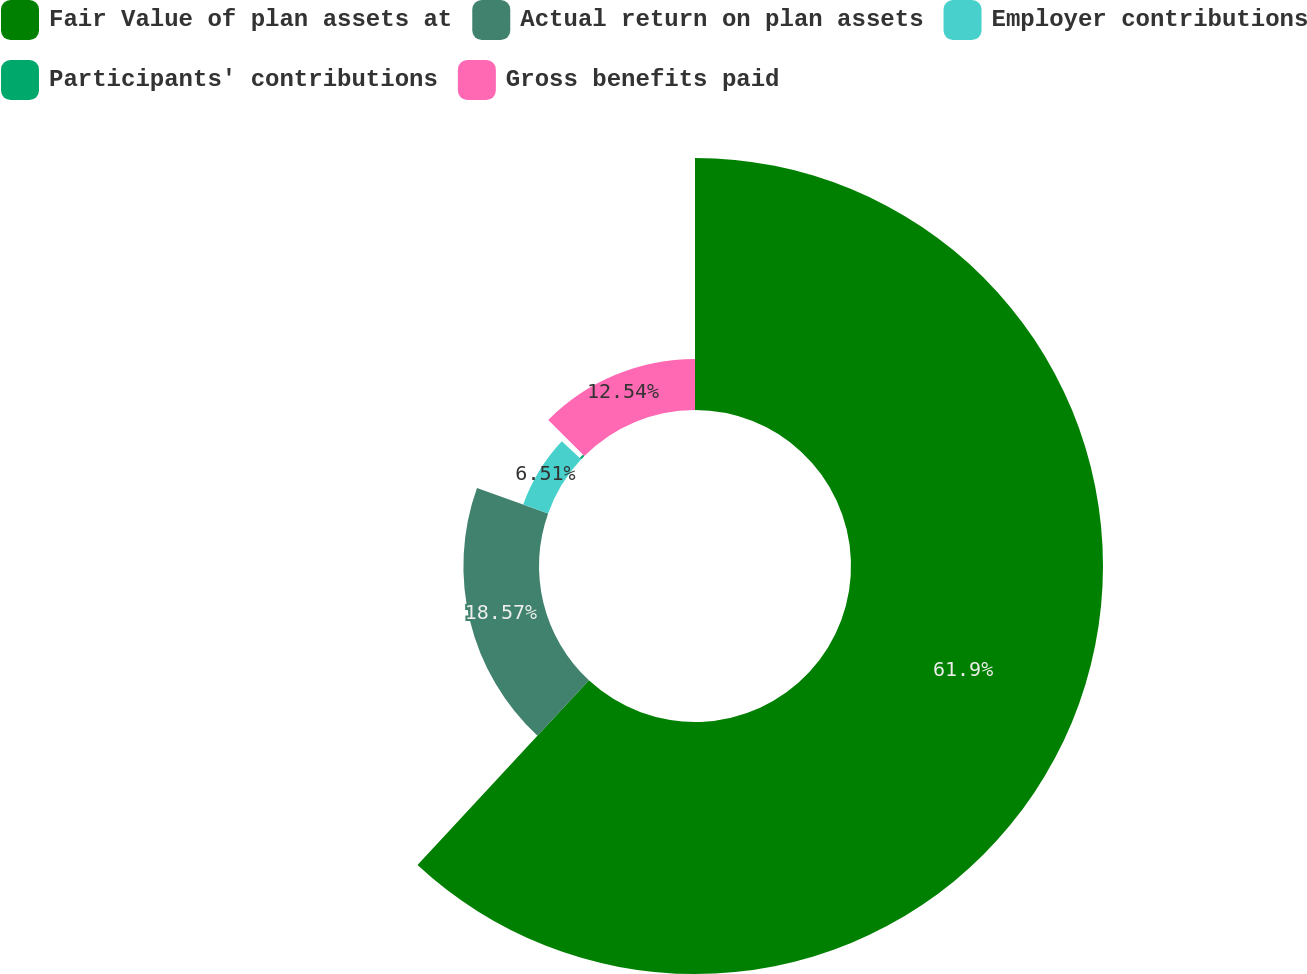Convert chart to OTSL. <chart><loc_0><loc_0><loc_500><loc_500><pie_chart><fcel>Fair Value of plan assets at<fcel>Actual return on plan assets<fcel>Employer contributions<fcel>Participants' contributions<fcel>Gross benefits paid<nl><fcel>61.91%<fcel>18.57%<fcel>6.51%<fcel>0.48%<fcel>12.54%<nl></chart> 